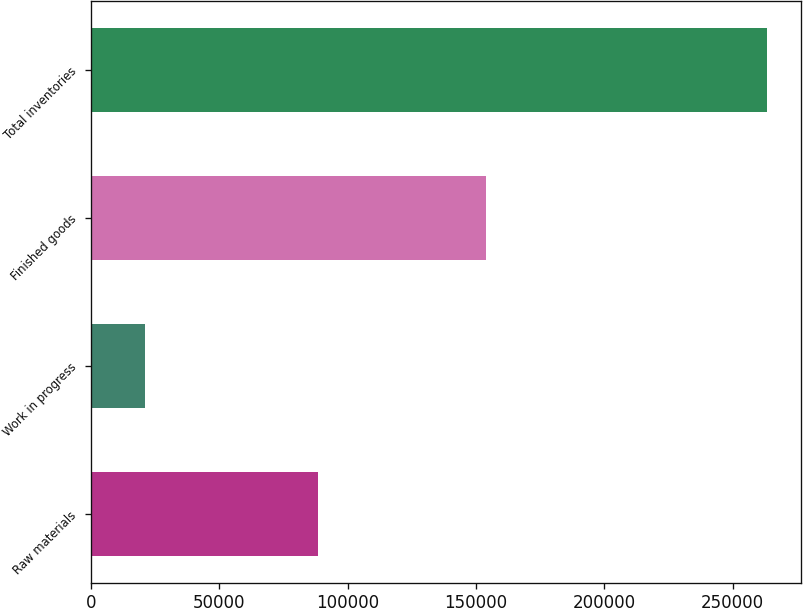Convert chart. <chart><loc_0><loc_0><loc_500><loc_500><bar_chart><fcel>Raw materials<fcel>Work in progress<fcel>Finished goods<fcel>Total inventories<nl><fcel>88625<fcel>20901<fcel>153889<fcel>263415<nl></chart> 